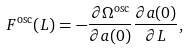Convert formula to latex. <formula><loc_0><loc_0><loc_500><loc_500>F ^ { \text {osc} } ( L ) = - \frac { \partial \Omega ^ { \text {osc} } } { \partial a ( 0 ) } \frac { \partial a ( 0 ) } { \partial L } ,</formula> 